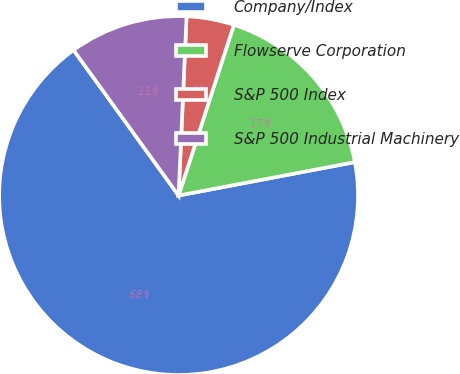Convert chart to OTSL. <chart><loc_0><loc_0><loc_500><loc_500><pie_chart><fcel>Company/Index<fcel>Flowserve Corporation<fcel>S&P 500 Index<fcel>S&P 500 Industrial Machinery<nl><fcel>68.03%<fcel>17.03%<fcel>4.28%<fcel>10.66%<nl></chart> 